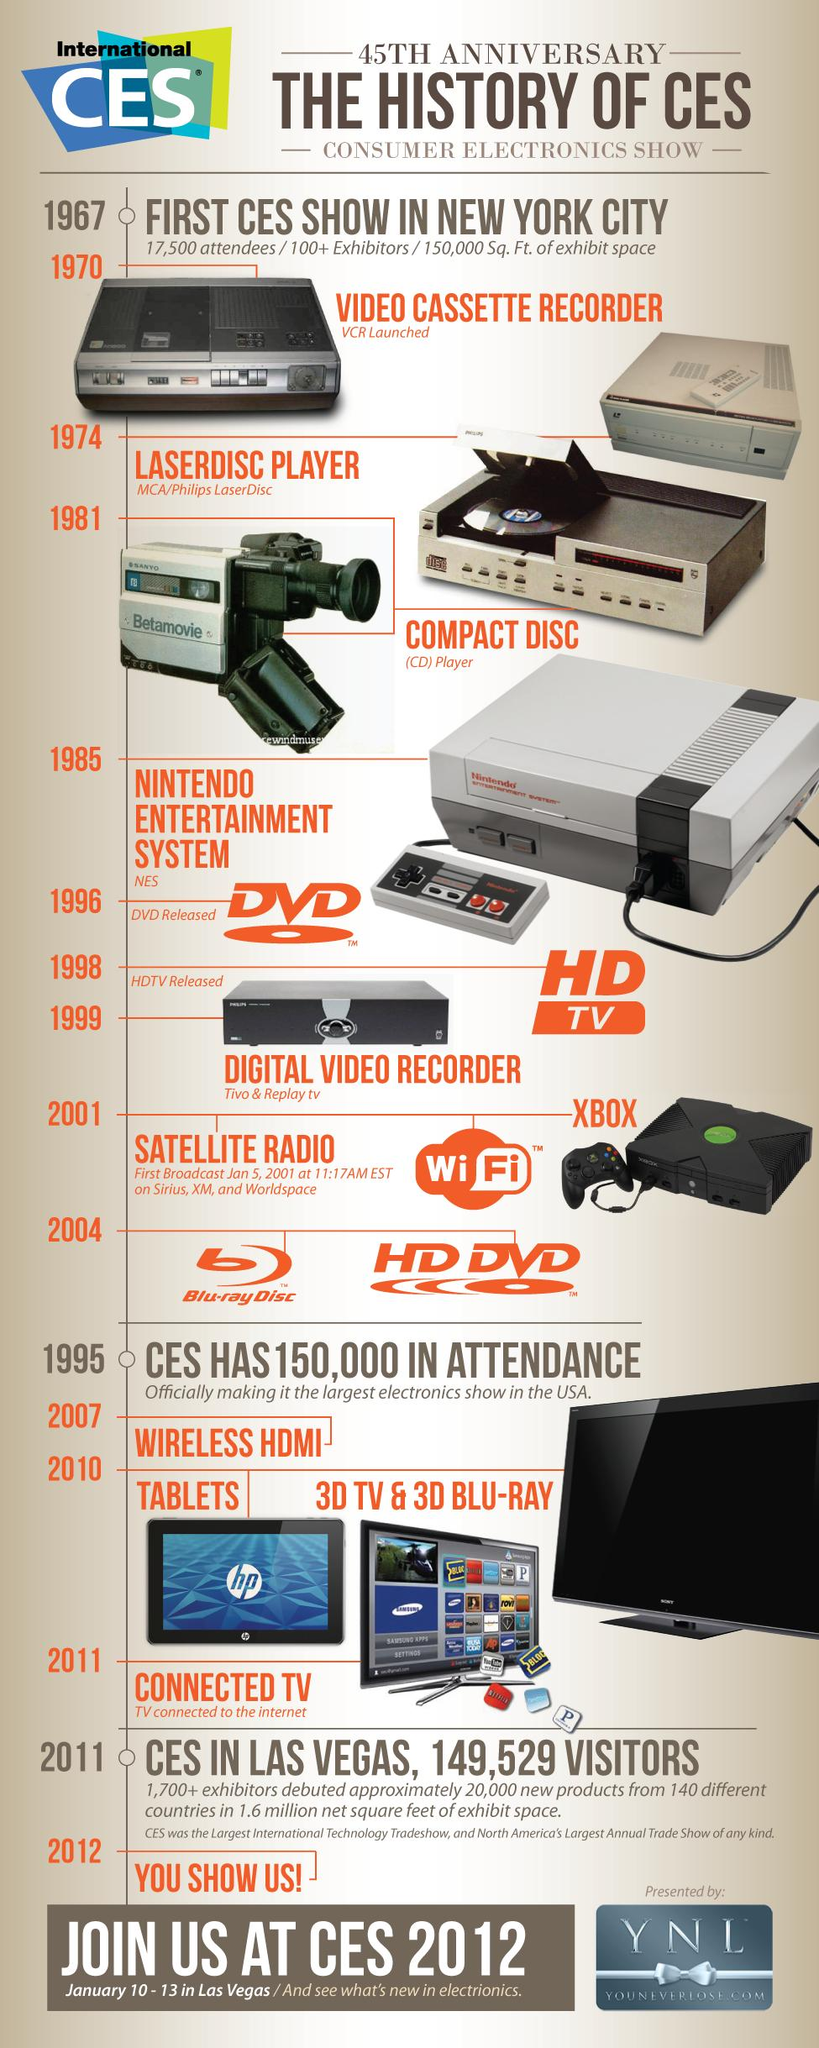Point out several critical features in this image. This infographic contains one DVD image. The infographic contains 1.. tablets. The number of television images in this infographic is two. 